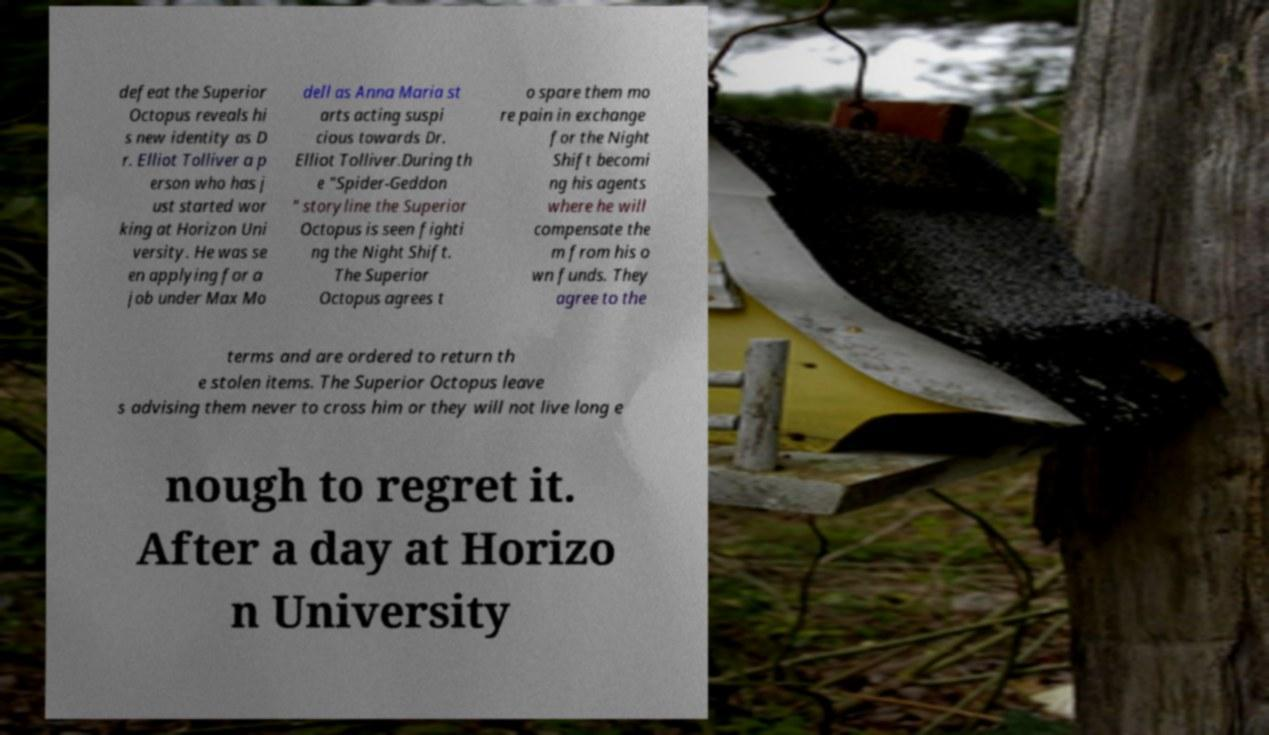For documentation purposes, I need the text within this image transcribed. Could you provide that? defeat the Superior Octopus reveals hi s new identity as D r. Elliot Tolliver a p erson who has j ust started wor king at Horizon Uni versity. He was se en applying for a job under Max Mo dell as Anna Maria st arts acting suspi cious towards Dr. Elliot Tolliver.During th e "Spider-Geddon " storyline the Superior Octopus is seen fighti ng the Night Shift. The Superior Octopus agrees t o spare them mo re pain in exchange for the Night Shift becomi ng his agents where he will compensate the m from his o wn funds. They agree to the terms and are ordered to return th e stolen items. The Superior Octopus leave s advising them never to cross him or they will not live long e nough to regret it. After a day at Horizo n University 